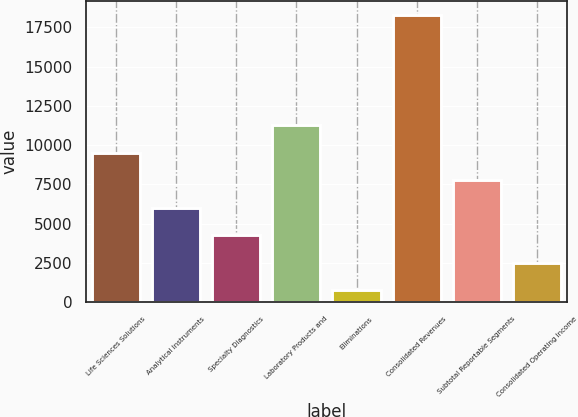<chart> <loc_0><loc_0><loc_500><loc_500><bar_chart><fcel>Life Sciences Solutions<fcel>Analytical Instruments<fcel>Specialty Diagnostics<fcel>Laboratory Products and<fcel>Eliminations<fcel>Consolidated Revenues<fcel>Subtotal Reportable Segments<fcel>Consolidated Operating Income<nl><fcel>9524<fcel>6024<fcel>4274<fcel>11274<fcel>774<fcel>18274<fcel>7774<fcel>2524<nl></chart> 